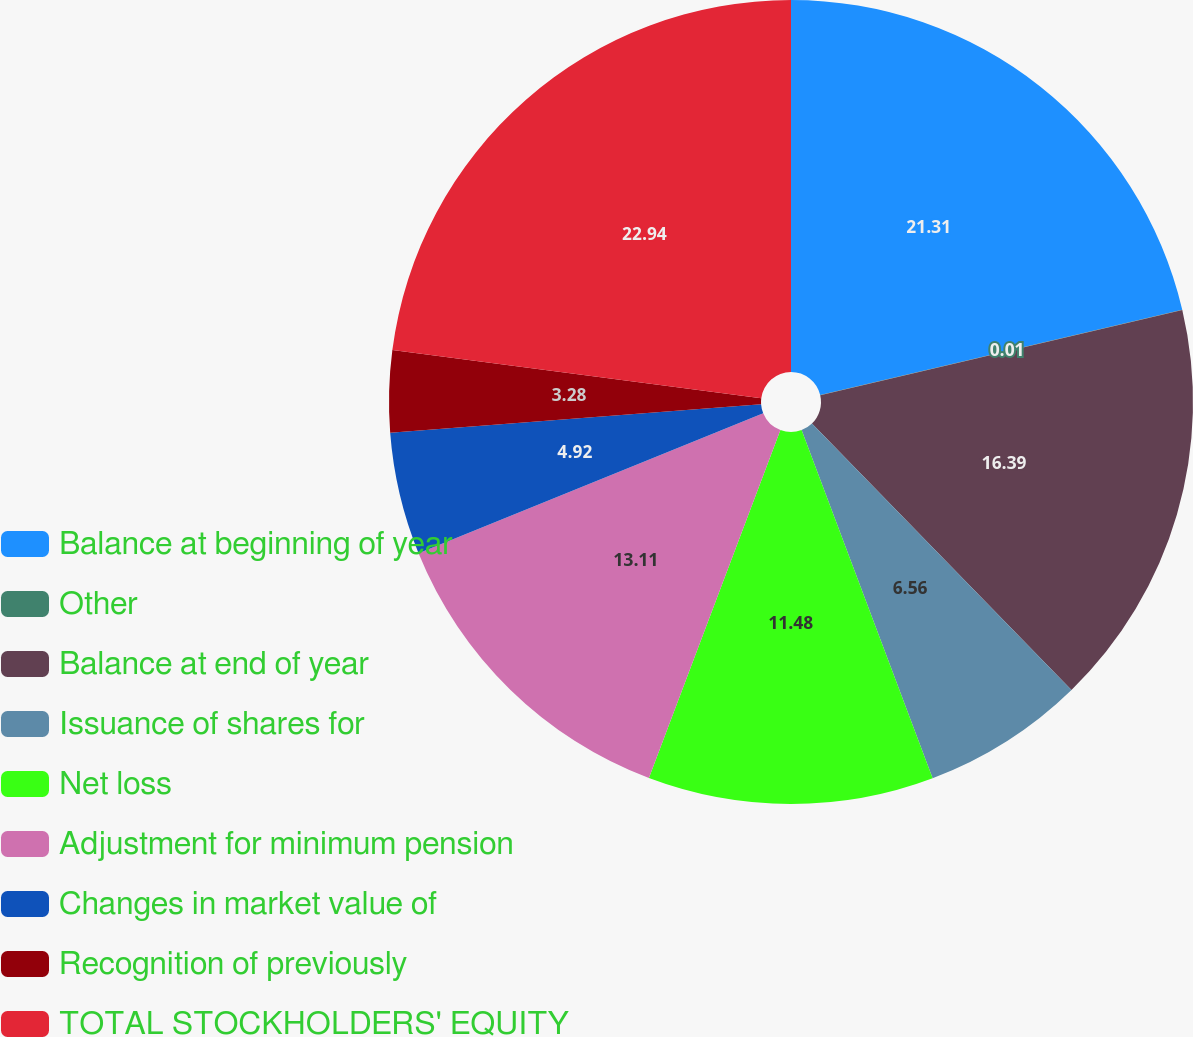<chart> <loc_0><loc_0><loc_500><loc_500><pie_chart><fcel>Balance at beginning of year<fcel>Other<fcel>Balance at end of year<fcel>Issuance of shares for<fcel>Net loss<fcel>Adjustment for minimum pension<fcel>Changes in market value of<fcel>Recognition of previously<fcel>TOTAL STOCKHOLDERS' EQUITY<nl><fcel>21.31%<fcel>0.01%<fcel>16.39%<fcel>6.56%<fcel>11.48%<fcel>13.11%<fcel>4.92%<fcel>3.28%<fcel>22.94%<nl></chart> 